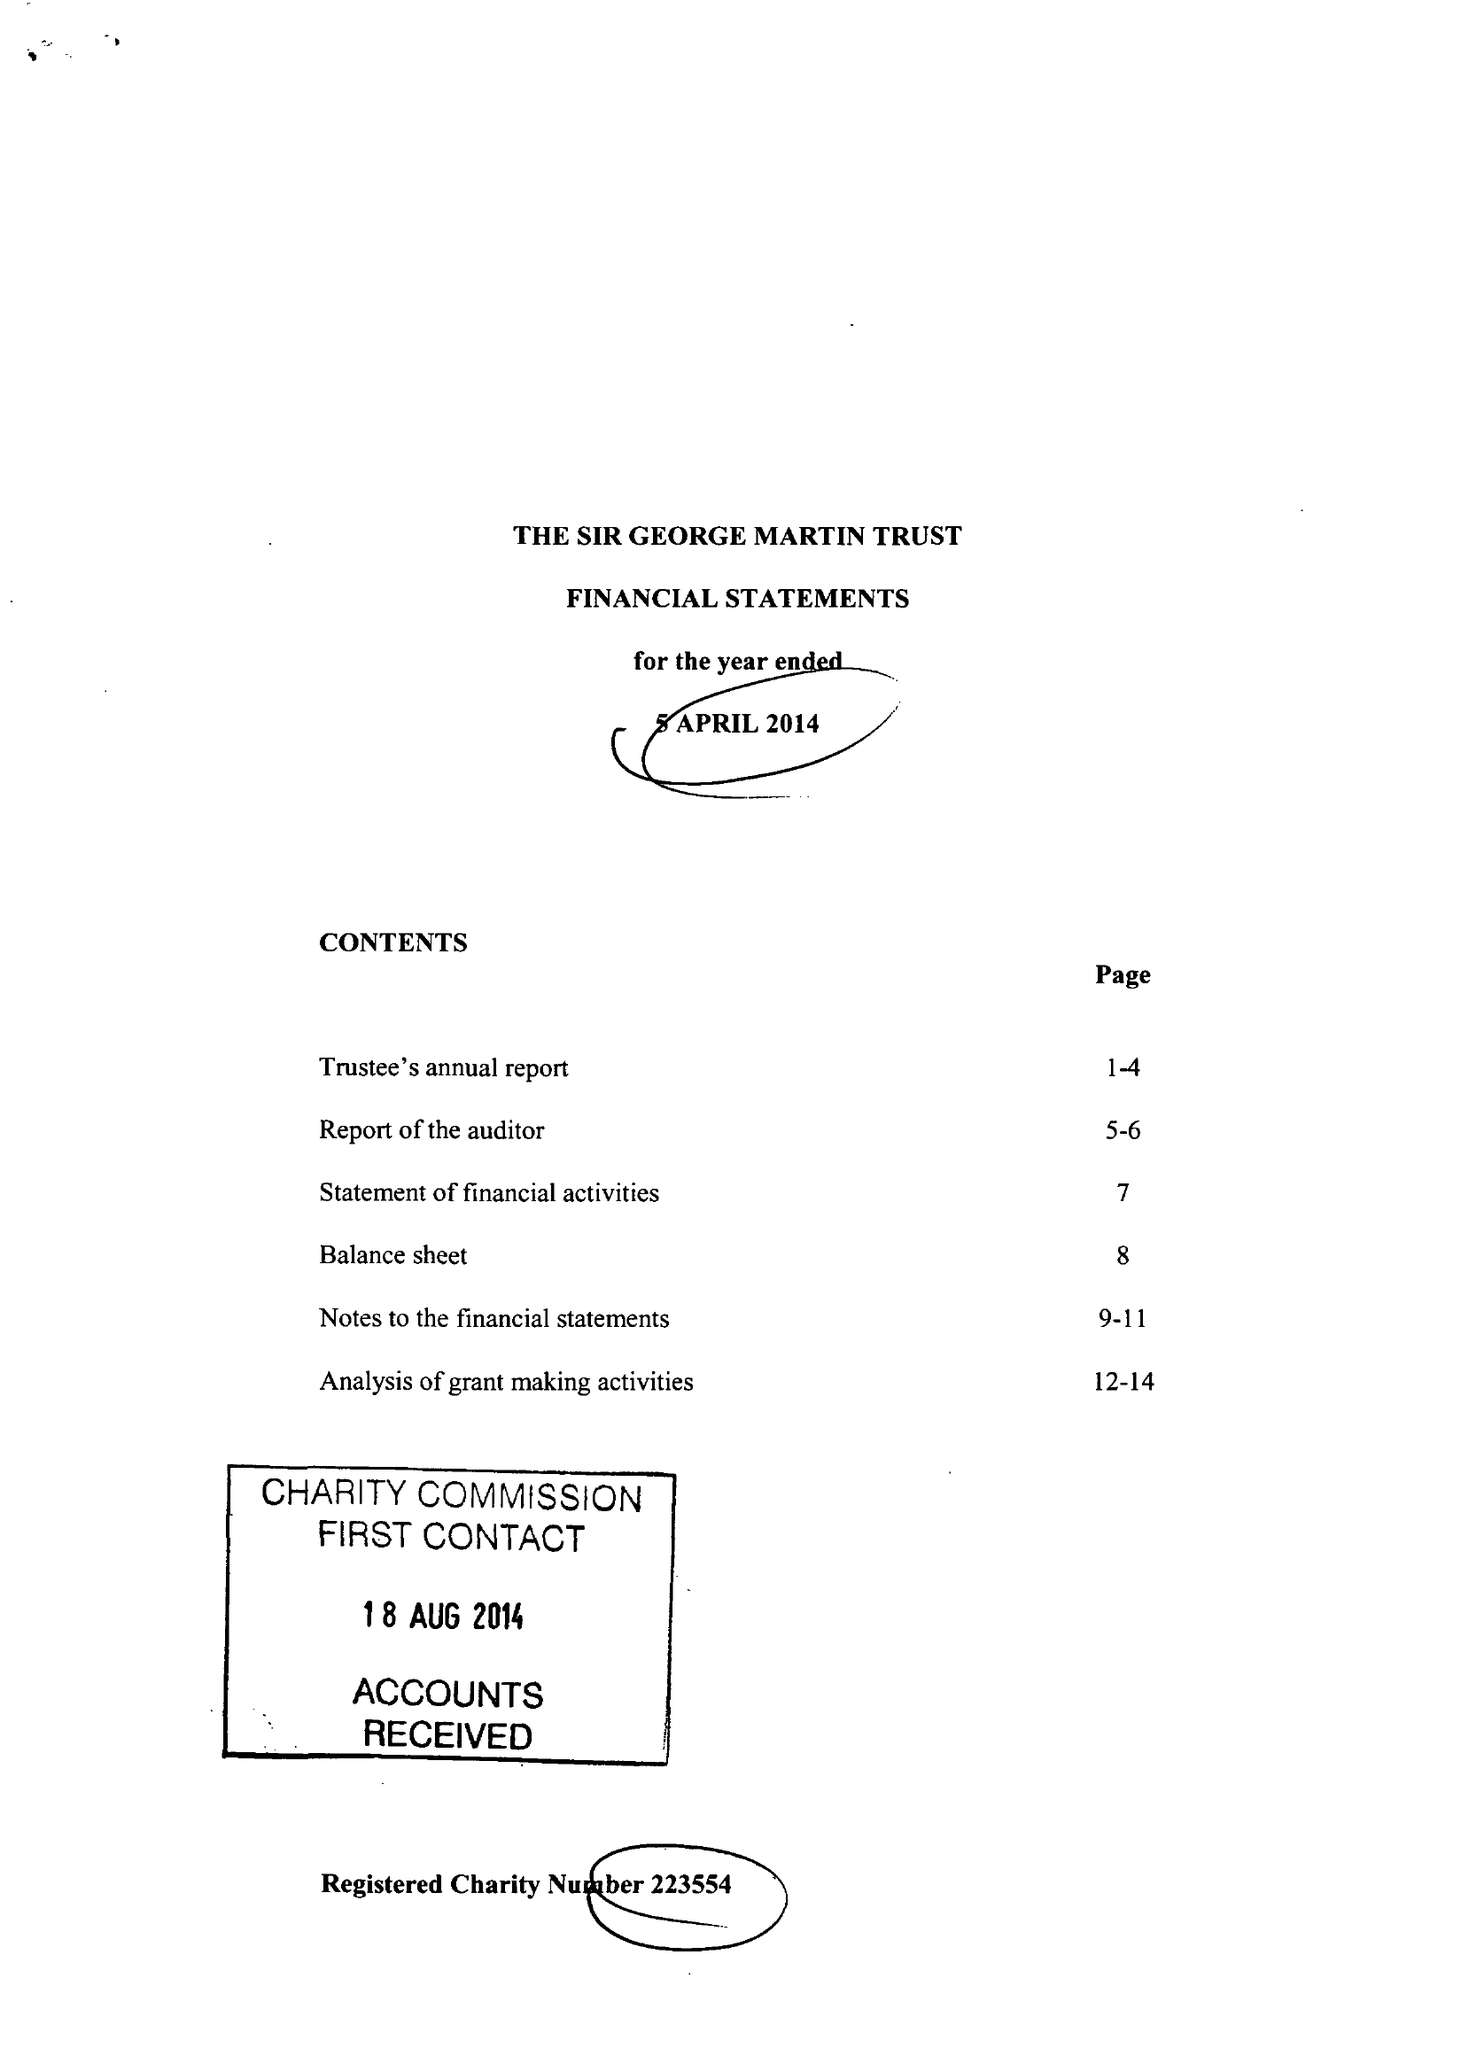What is the value for the income_annually_in_british_pounds?
Answer the question using a single word or phrase. 125149.00 